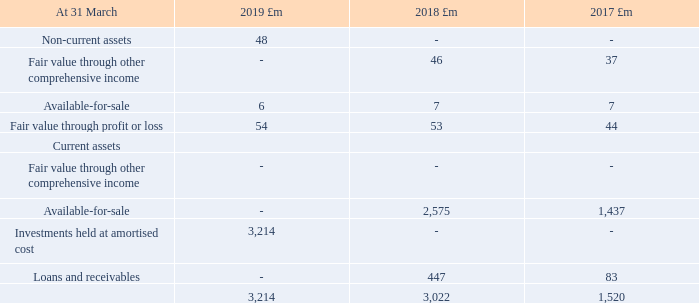23. Investments continued
IFRS 9 was applied for the first time on 1 April 2018 and introduces new classifications for financial instruments, including investments. Under IAS 39, we classified investments as available-for-sale, loans and receivables, and fair value through profit or loss. On transition to IFRS 9 we have reclassified them as fair value through other comprehensive income, fair value through profit or loss, and amortised cost, as set out in note 1. The current year figures in the following table reflect the classifications under IFRS 9, and the prior year figures reflect the previous classifications under IAS 39.
Investments held at amortised cost consist of investments previously classified as loans and receivables and relate to money market investments denominated in sterling of £2,687m (2017/18: £416m, 2016/17: £35m), in US dollars of £26m (2017/18: £27m, 2016/17: £30m) in euros of £499m (2017/18: £nil, 2016/17: £nil) and in other currencies £2m (2017/18: £4m, 2016/17: £18m). They also include investments in liquidity funds of £2,522m (2017/18: £2,575m, 2016/17: £1,437m) held to collect contractual cash flows. In prior years these were classified as available-for-sale.
What were the  Fair value through profit or loss  in 2019, 2018 and 2017 respectively?
Answer scale should be: million. 54, 53, 44. What were the investments in liquidity funds in 2019, 2018 and 2017 respectively? £2,522m, £2,575m, £1,437m. When was the IFRS 9 applied? 1 april 2018. What is the change in the Fair value through other comprehensive income from 2017 to 2018?
Answer scale should be: million. 46 - 37
Answer: 9. Which year(s) has Fair value through profit or loss greater than 50 million? Identify the fair value through profit or loss in row 5
answer: 2019, 2018. What is the average Loans and receivables for 2017-2019?
Answer scale should be: million. (0 + 447 + 83) / 3
Answer: 176.67. 